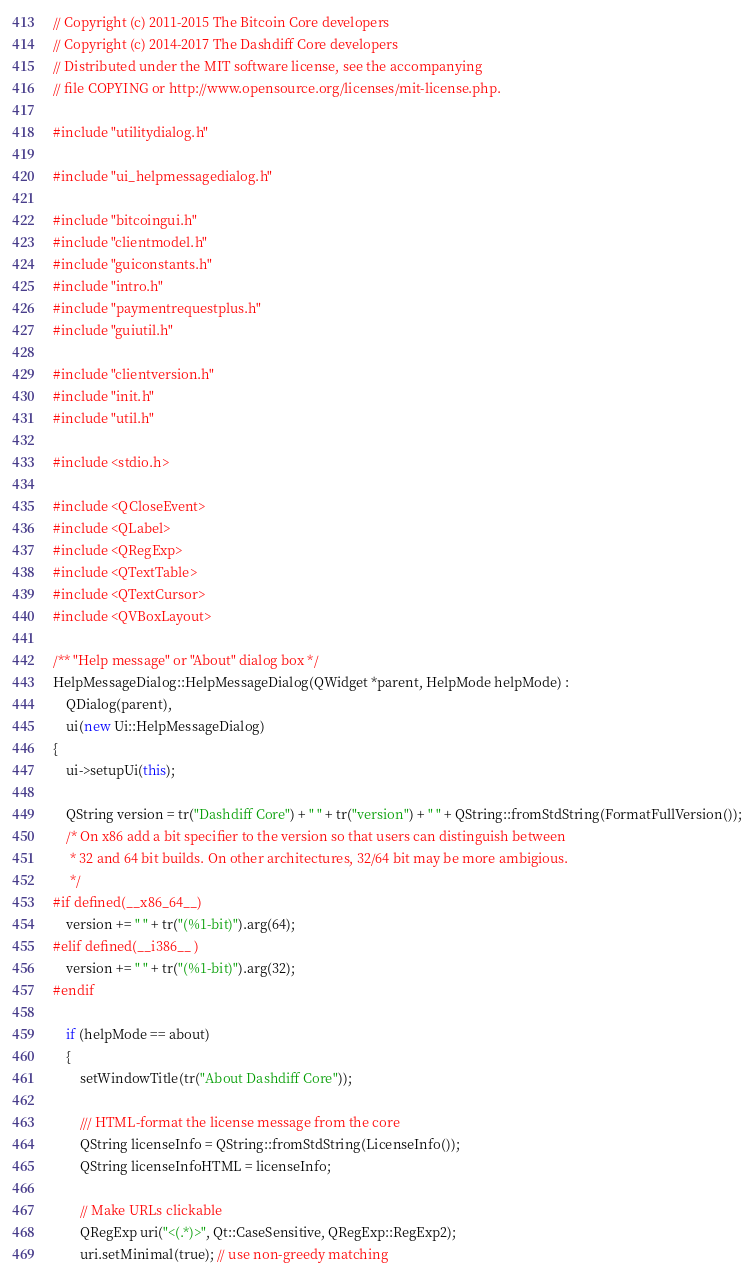Convert code to text. <code><loc_0><loc_0><loc_500><loc_500><_C++_>// Copyright (c) 2011-2015 The Bitcoin Core developers
// Copyright (c) 2014-2017 The Dashdiff Core developers
// Distributed under the MIT software license, see the accompanying
// file COPYING or http://www.opensource.org/licenses/mit-license.php.

#include "utilitydialog.h"

#include "ui_helpmessagedialog.h"

#include "bitcoingui.h"
#include "clientmodel.h"
#include "guiconstants.h"
#include "intro.h"
#include "paymentrequestplus.h"
#include "guiutil.h"

#include "clientversion.h"
#include "init.h"
#include "util.h"

#include <stdio.h>

#include <QCloseEvent>
#include <QLabel>
#include <QRegExp>
#include <QTextTable>
#include <QTextCursor>
#include <QVBoxLayout>

/** "Help message" or "About" dialog box */
HelpMessageDialog::HelpMessageDialog(QWidget *parent, HelpMode helpMode) :
    QDialog(parent),
    ui(new Ui::HelpMessageDialog)
{
    ui->setupUi(this);

    QString version = tr("Dashdiff Core") + " " + tr("version") + " " + QString::fromStdString(FormatFullVersion());
    /* On x86 add a bit specifier to the version so that users can distinguish between
     * 32 and 64 bit builds. On other architectures, 32/64 bit may be more ambigious.
     */
#if defined(__x86_64__)
    version += " " + tr("(%1-bit)").arg(64);
#elif defined(__i386__ )
    version += " " + tr("(%1-bit)").arg(32);
#endif

    if (helpMode == about)
    {
        setWindowTitle(tr("About Dashdiff Core"));

        /// HTML-format the license message from the core
        QString licenseInfo = QString::fromStdString(LicenseInfo());
        QString licenseInfoHTML = licenseInfo;

        // Make URLs clickable
        QRegExp uri("<(.*)>", Qt::CaseSensitive, QRegExp::RegExp2);
        uri.setMinimal(true); // use non-greedy matching</code> 